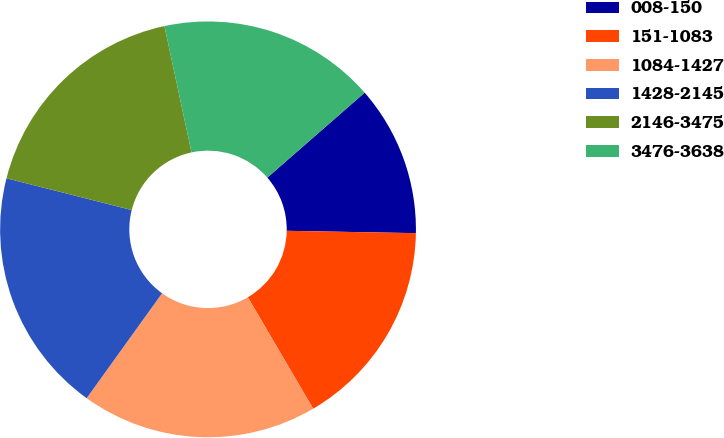<chart> <loc_0><loc_0><loc_500><loc_500><pie_chart><fcel>008-150<fcel>151-1083<fcel>1084-1427<fcel>1428-2145<fcel>2146-3475<fcel>3476-3638<nl><fcel>11.71%<fcel>16.27%<fcel>18.36%<fcel>19.03%<fcel>17.69%<fcel>16.94%<nl></chart> 